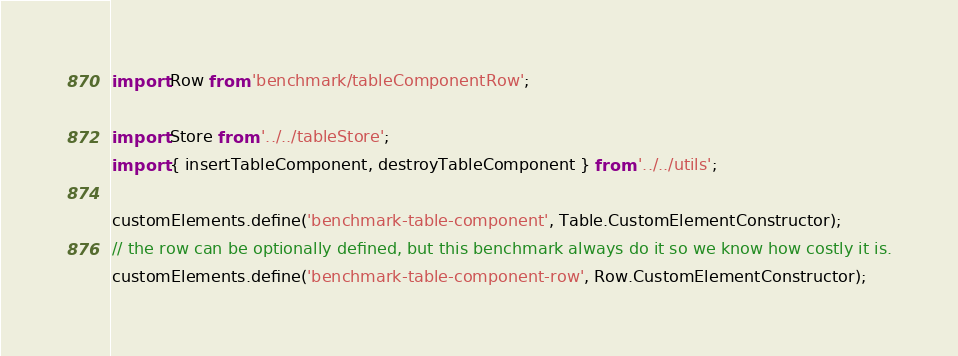Convert code to text. <code><loc_0><loc_0><loc_500><loc_500><_JavaScript_>import Row from 'benchmark/tableComponentRow';

import Store from '../../tableStore';
import { insertTableComponent, destroyTableComponent } from '../../utils';

customElements.define('benchmark-table-component', Table.CustomElementConstructor);
// the row can be optionally defined, but this benchmark always do it so we know how costly it is.
customElements.define('benchmark-table-component-row', Row.CustomElementConstructor);
</code> 